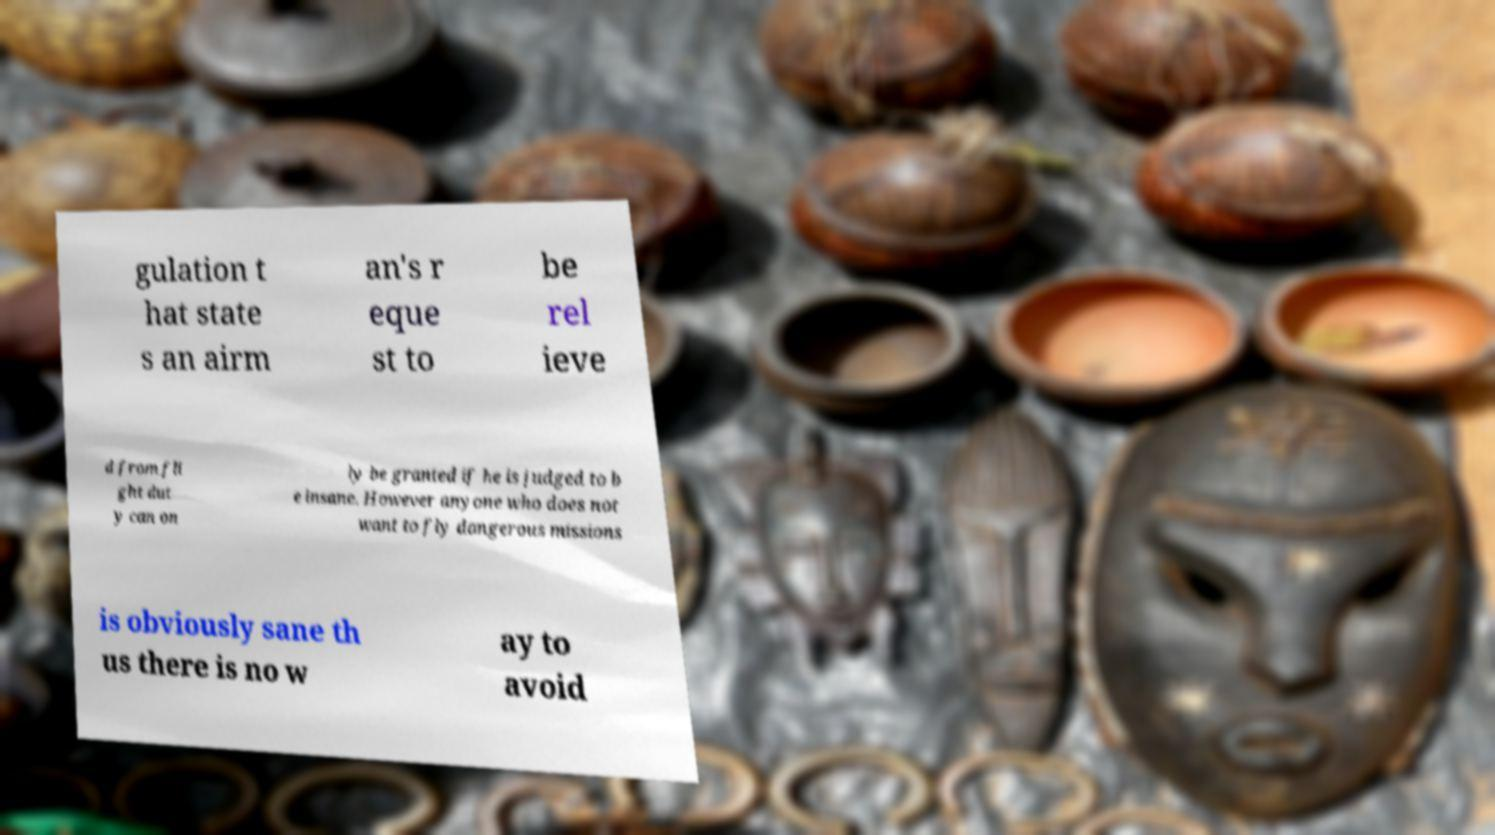I need the written content from this picture converted into text. Can you do that? gulation t hat state s an airm an's r eque st to be rel ieve d from fli ght dut y can on ly be granted if he is judged to b e insane. However anyone who does not want to fly dangerous missions is obviously sane th us there is no w ay to avoid 